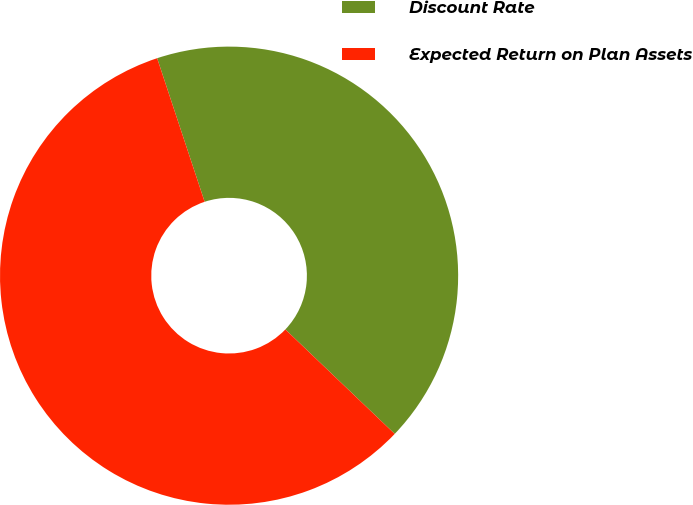<chart> <loc_0><loc_0><loc_500><loc_500><pie_chart><fcel>Discount Rate<fcel>Expected Return on Plan Assets<nl><fcel>42.22%<fcel>57.78%<nl></chart> 